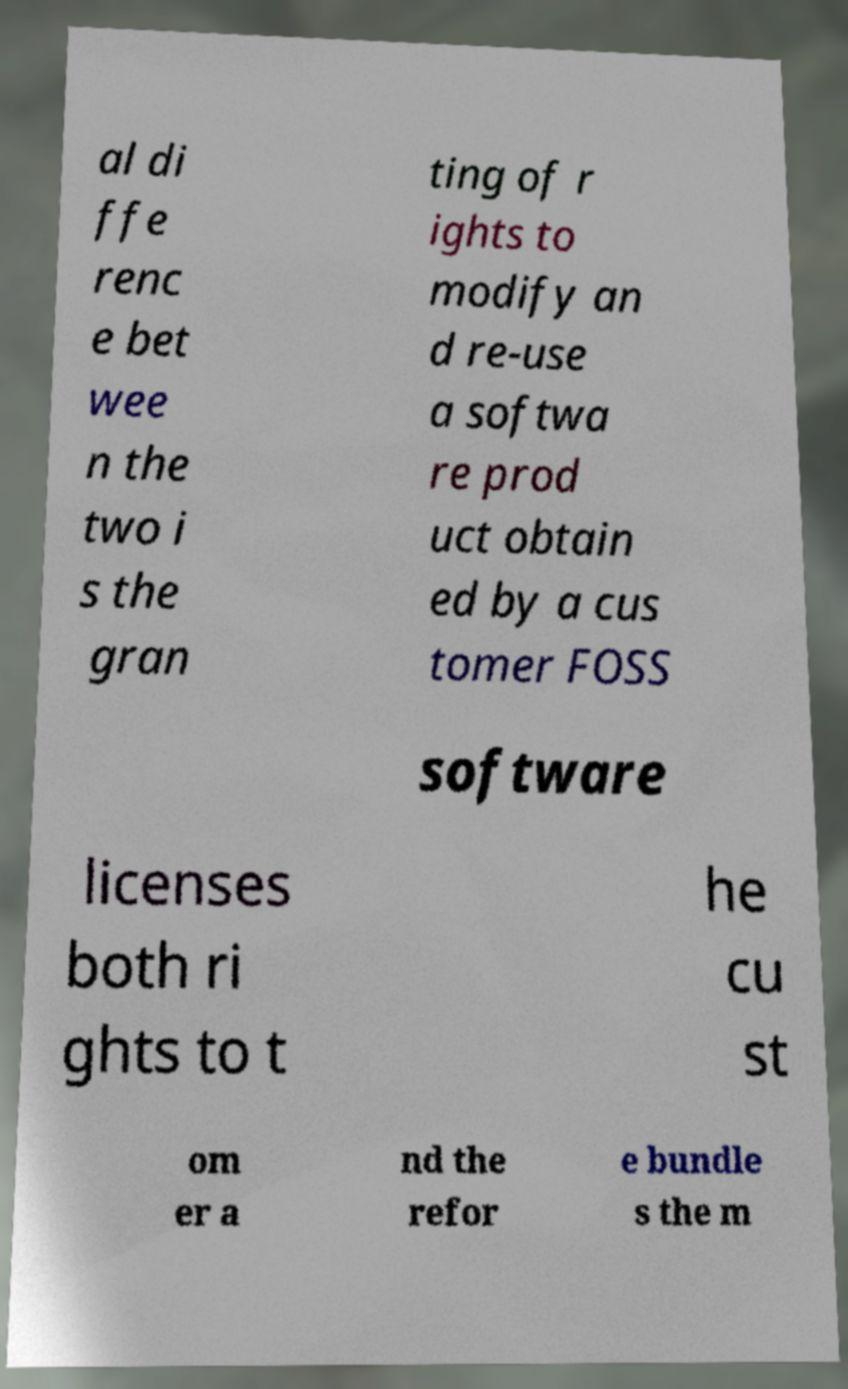Please read and relay the text visible in this image. What does it say? al di ffe renc e bet wee n the two i s the gran ting of r ights to modify an d re-use a softwa re prod uct obtain ed by a cus tomer FOSS software licenses both ri ghts to t he cu st om er a nd the refor e bundle s the m 